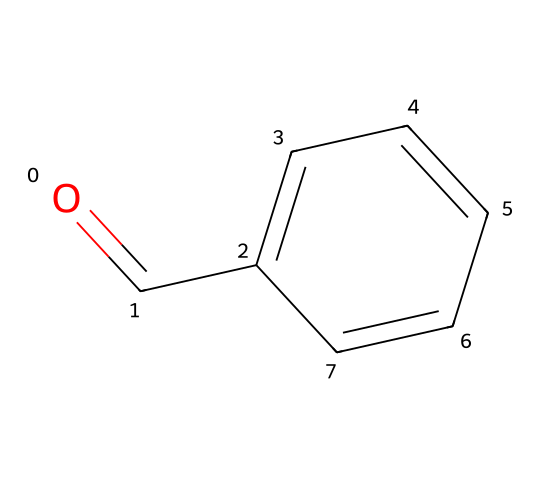What is the main functional group present in this chemical? The chemical structure shows a carbonyl group (C=O) attached to a benzene ring, which confirms the presence of the aldehyde functional group.
Answer: aldehyde How many carbon atoms are in benzaldehyde? The SMILES representation reveals that there are six carbon atoms from the benzene ring and one carbon from the carbonyl group, totaling seven carbon atoms.
Answer: seven What type of aroma does benzaldehyde typically have? Benzaldehyde is known to have a characteristic almond-like aroma, which is a common descriptor for its sensory properties.
Answer: almond How many hydrogen atoms are present in benzaldehyde? The structure displays six hydrogen atoms from the benzene ring and one from the carbonyl group, leading to a total of six hydrogen atoms, as one hydrogen from the aldehyde carbon is not present due to the C=O bond.
Answer: six What is the role of benzaldehyde in military-grade smoke grenades? Benzaldehyde acts as a component that can influence the generation of smoke and can also have impact on the color and toxicity of the smoke produced during combustion.
Answer: smoke component Is benzaldehyde a saturated or unsaturated compound? Presence of the double bond in the carbonyl group indicates that benzaldehyde is unsaturated because it has at least one double bond in its structure.
Answer: unsaturated 